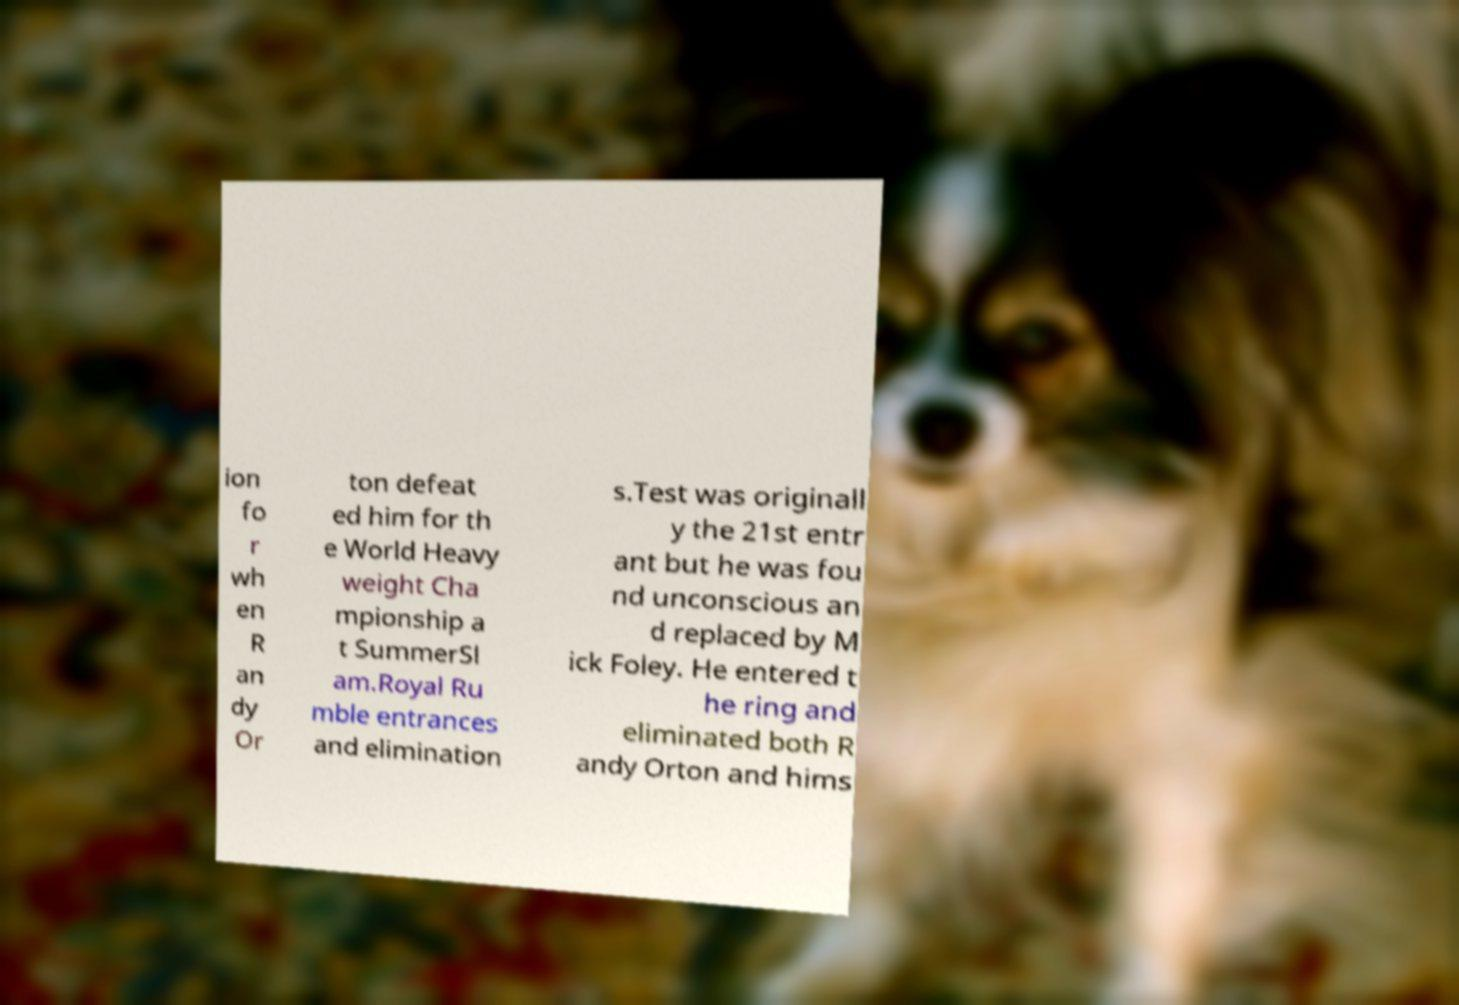I need the written content from this picture converted into text. Can you do that? ion fo r wh en R an dy Or ton defeat ed him for th e World Heavy weight Cha mpionship a t SummerSl am.Royal Ru mble entrances and elimination s.Test was originall y the 21st entr ant but he was fou nd unconscious an d replaced by M ick Foley. He entered t he ring and eliminated both R andy Orton and hims 